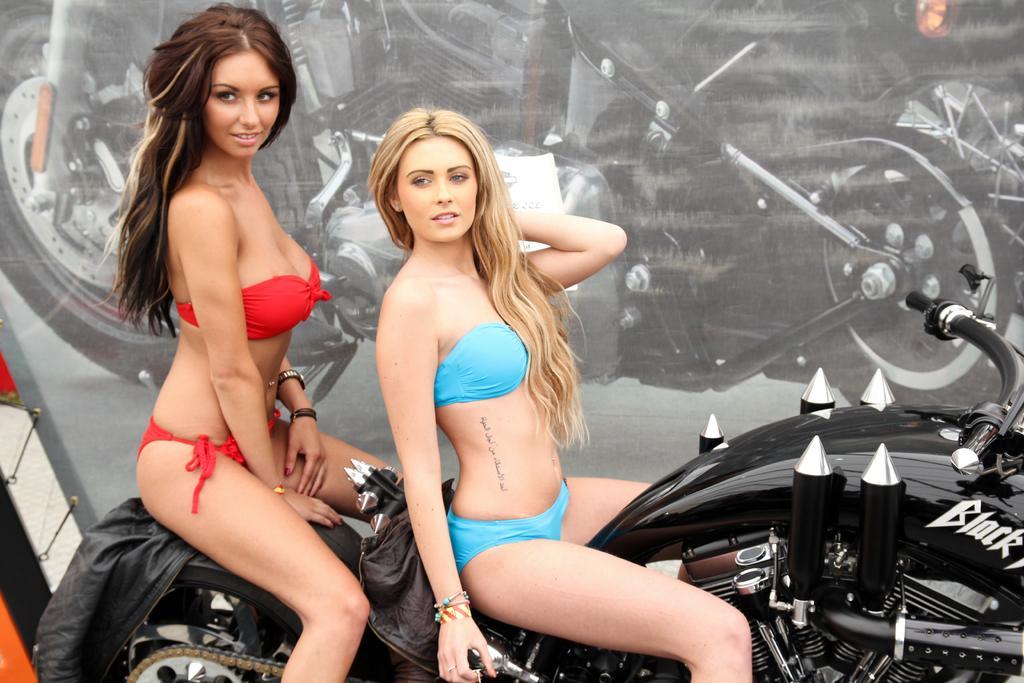Could you give a brief overview of what you see in this image? In this image I see 2 girls and both of them are sitting on the bike and both of them are smiling. 